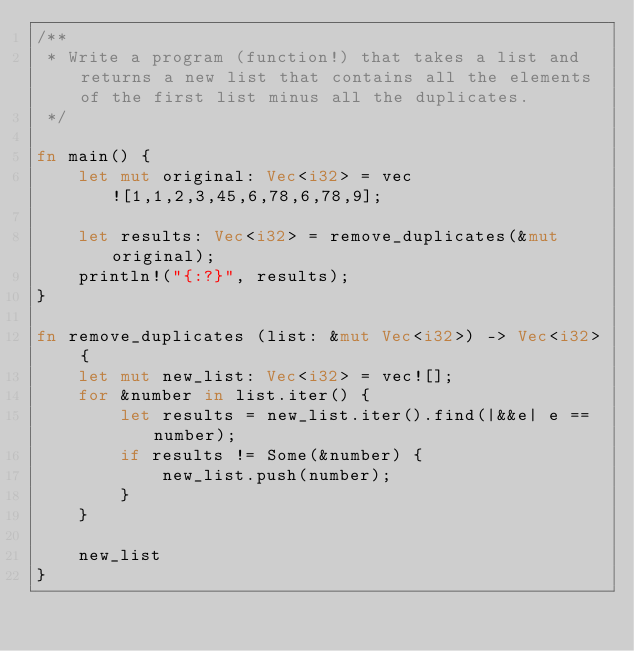<code> <loc_0><loc_0><loc_500><loc_500><_Rust_>/**
 * Write a program (function!) that takes a list and returns a new list that contains all the elements of the first list minus all the duplicates.
 */

fn main() {
    let mut original: Vec<i32> = vec![1,1,2,3,45,6,78,6,78,9];

    let results: Vec<i32> = remove_duplicates(&mut original);
    println!("{:?}", results);
}

fn remove_duplicates (list: &mut Vec<i32>) -> Vec<i32> {
    let mut new_list: Vec<i32> = vec![];
    for &number in list.iter() {
        let results = new_list.iter().find(|&&e| e == number);
        if results != Some(&number) {
            new_list.push(number);
        }
    }

    new_list
}
</code> 